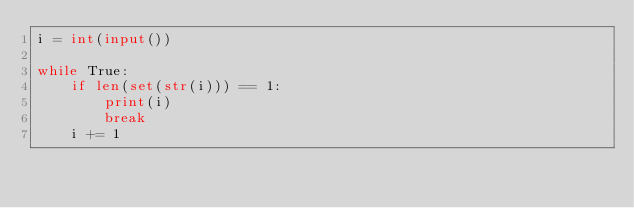Convert code to text. <code><loc_0><loc_0><loc_500><loc_500><_Python_>i = int(input())

while True:
    if len(set(str(i))) == 1:
        print(i)
        break
    i += 1</code> 